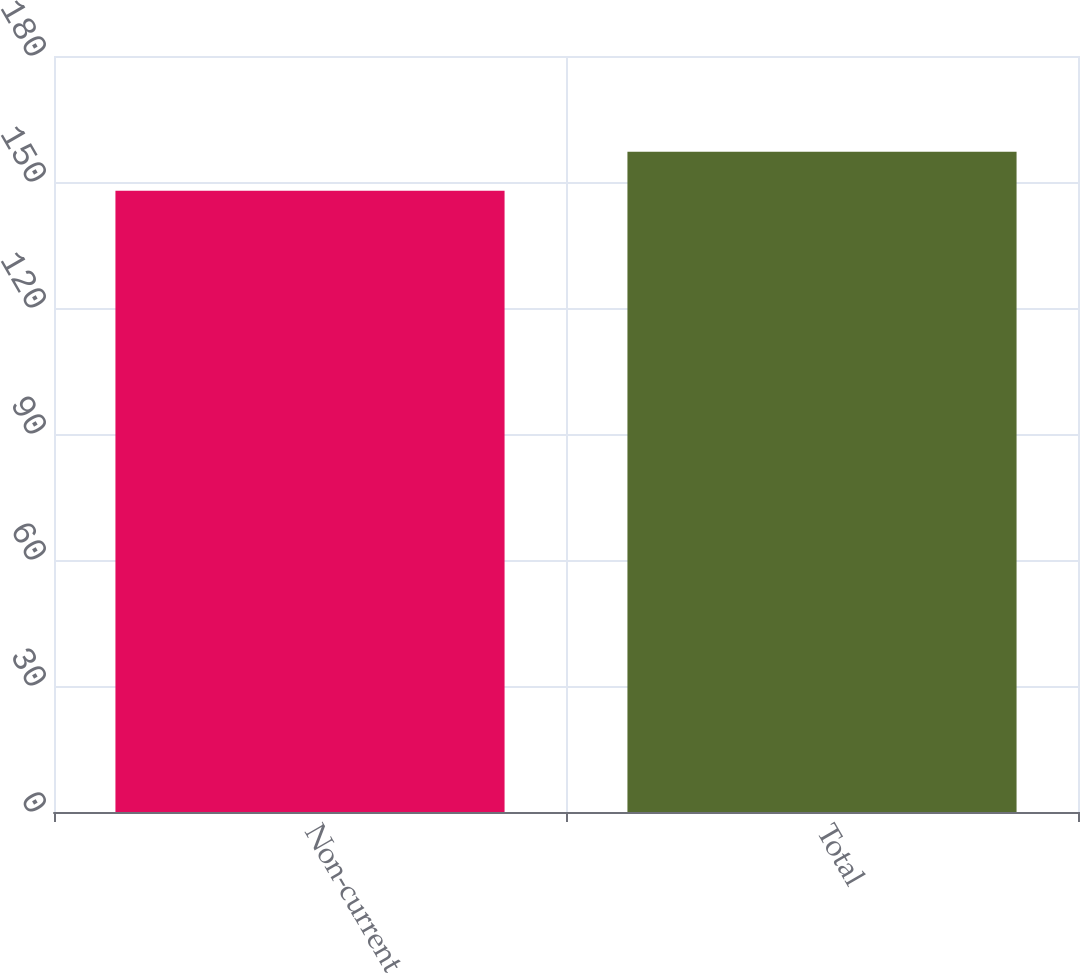Convert chart. <chart><loc_0><loc_0><loc_500><loc_500><bar_chart><fcel>Non-current<fcel>Total<nl><fcel>147.9<fcel>157.2<nl></chart> 